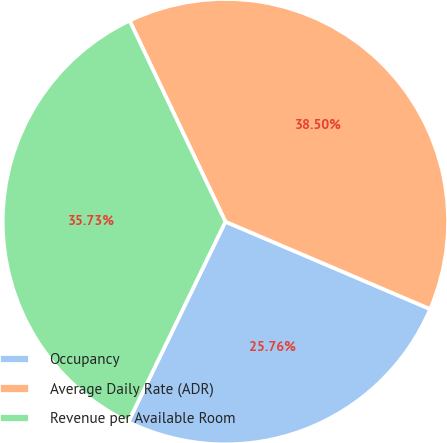<chart> <loc_0><loc_0><loc_500><loc_500><pie_chart><fcel>Occupancy<fcel>Average Daily Rate (ADR)<fcel>Revenue per Available Room<nl><fcel>25.76%<fcel>38.5%<fcel>35.73%<nl></chart> 